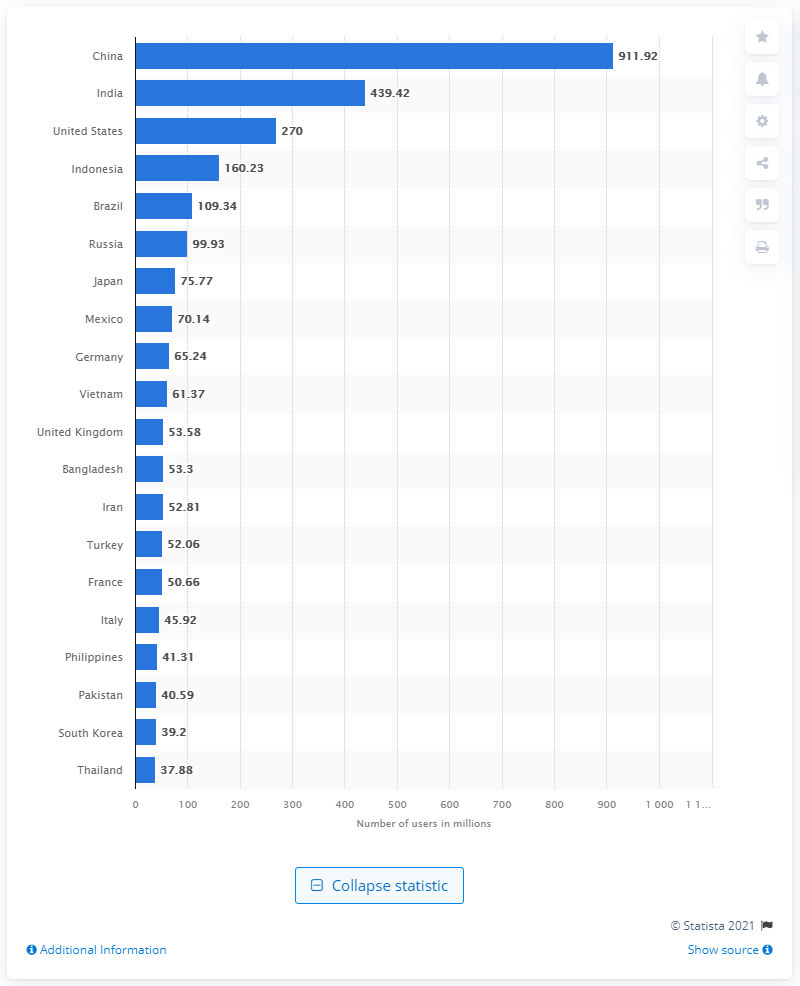Indicate a few pertinent items in this graphic. As of 2021, India had the second highest number of smartphone users among all countries in the world. In 2021, there were approximately 911.92 million smartphone users in China. 